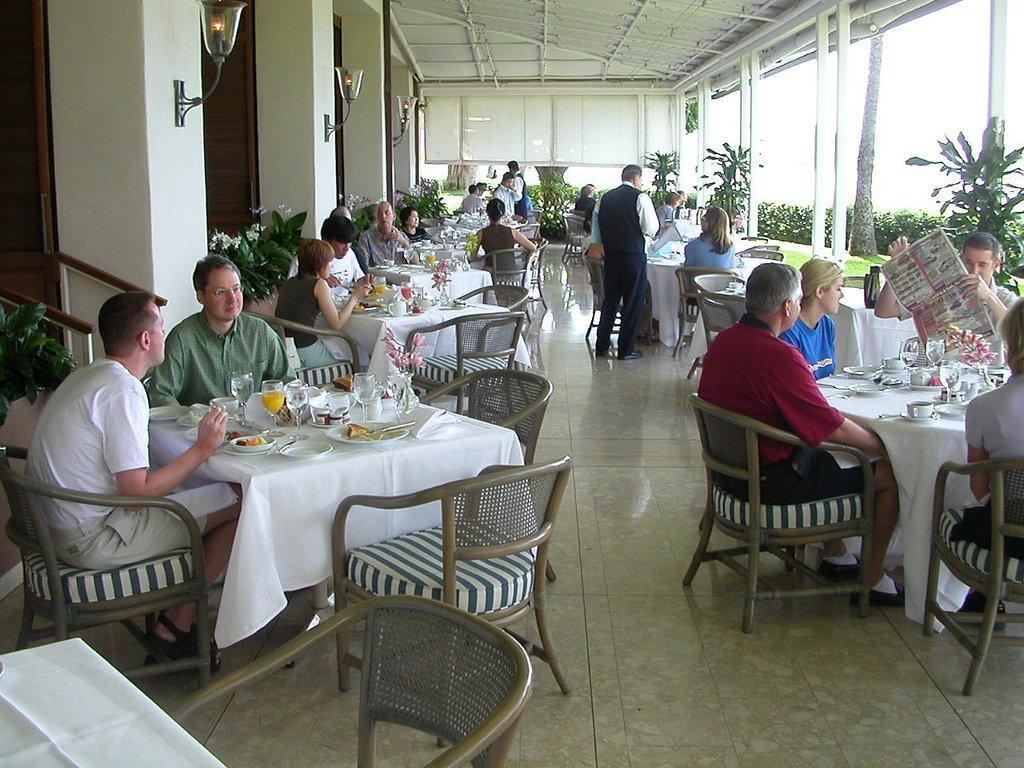In one or two sentences, can you explain what this image depicts? In this picture we can see a group of people sitting on chair and in front of them there is table and on table we can see glasses, plate, bottles, cup, saucer, flowers and some are standing and taking orders from this people and in background we can see wall, pillar, lamp, trees. 